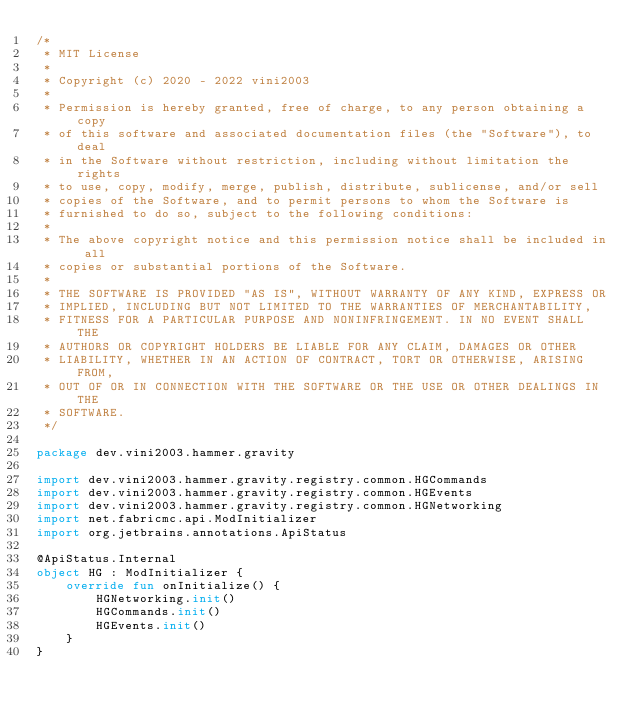<code> <loc_0><loc_0><loc_500><loc_500><_Kotlin_>/*
 * MIT License
 *
 * Copyright (c) 2020 - 2022 vini2003
 *
 * Permission is hereby granted, free of charge, to any person obtaining a copy
 * of this software and associated documentation files (the "Software"), to deal
 * in the Software without restriction, including without limitation the rights
 * to use, copy, modify, merge, publish, distribute, sublicense, and/or sell
 * copies of the Software, and to permit persons to whom the Software is
 * furnished to do so, subject to the following conditions:
 *
 * The above copyright notice and this permission notice shall be included in all
 * copies or substantial portions of the Software.
 *
 * THE SOFTWARE IS PROVIDED "AS IS", WITHOUT WARRANTY OF ANY KIND, EXPRESS OR
 * IMPLIED, INCLUDING BUT NOT LIMITED TO THE WARRANTIES OF MERCHANTABILITY,
 * FITNESS FOR A PARTICULAR PURPOSE AND NONINFRINGEMENT. IN NO EVENT SHALL THE
 * AUTHORS OR COPYRIGHT HOLDERS BE LIABLE FOR ANY CLAIM, DAMAGES OR OTHER
 * LIABILITY, WHETHER IN AN ACTION OF CONTRACT, TORT OR OTHERWISE, ARISING FROM,
 * OUT OF OR IN CONNECTION WITH THE SOFTWARE OR THE USE OR OTHER DEALINGS IN THE
 * SOFTWARE.
 */

package dev.vini2003.hammer.gravity

import dev.vini2003.hammer.gravity.registry.common.HGCommands
import dev.vini2003.hammer.gravity.registry.common.HGEvents
import dev.vini2003.hammer.gravity.registry.common.HGNetworking
import net.fabricmc.api.ModInitializer
import org.jetbrains.annotations.ApiStatus

@ApiStatus.Internal
object HG : ModInitializer {
	override fun onInitialize() {
		HGNetworking.init()
		HGCommands.init()
		HGEvents.init()
	}
}</code> 